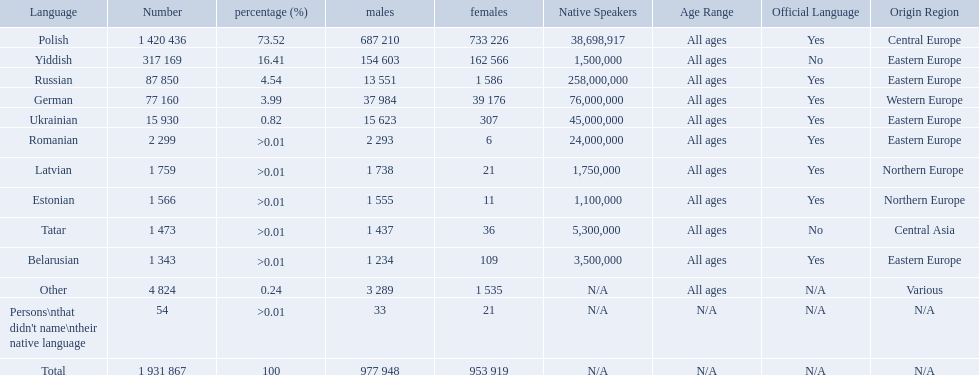What named native languages spoken in the warsaw governorate have more males then females? Russian, Ukrainian, Romanian, Latvian, Estonian, Tatar, Belarusian. Which of those have less then 500 males listed? Romanian, Latvian, Estonian, Tatar, Belarusian. Of the remaining languages which of them have less then 20 females? Romanian, Estonian. Which of these has the highest total number listed? Romanian. What are all the languages? Polish, Yiddish, Russian, German, Ukrainian, Romanian, Latvian, Estonian, Tatar, Belarusian, Other, Persons\nthat didn't name\ntheir native language. Of those languages, which five had fewer than 50 females speaking it? 6, 21, 11, 36, 21. Of those five languages, which is the lowest? Romanian. What languages are spoken in the warsaw governorate? Polish, Yiddish, Russian, German, Ukrainian, Romanian, Latvian, Estonian, Tatar, Belarusian. Which are the top five languages? Polish, Yiddish, Russian, German, Ukrainian. Of those which is the 2nd most frequently spoken? Yiddish. Which languages had percentages of >0.01? Romanian, Latvian, Estonian, Tatar, Belarusian. What was the top language? Romanian. How many languages are shown? Polish, Yiddish, Russian, German, Ukrainian, Romanian, Latvian, Estonian, Tatar, Belarusian, Other. What language is in third place? Russian. What language is the most spoken after that one? German. 